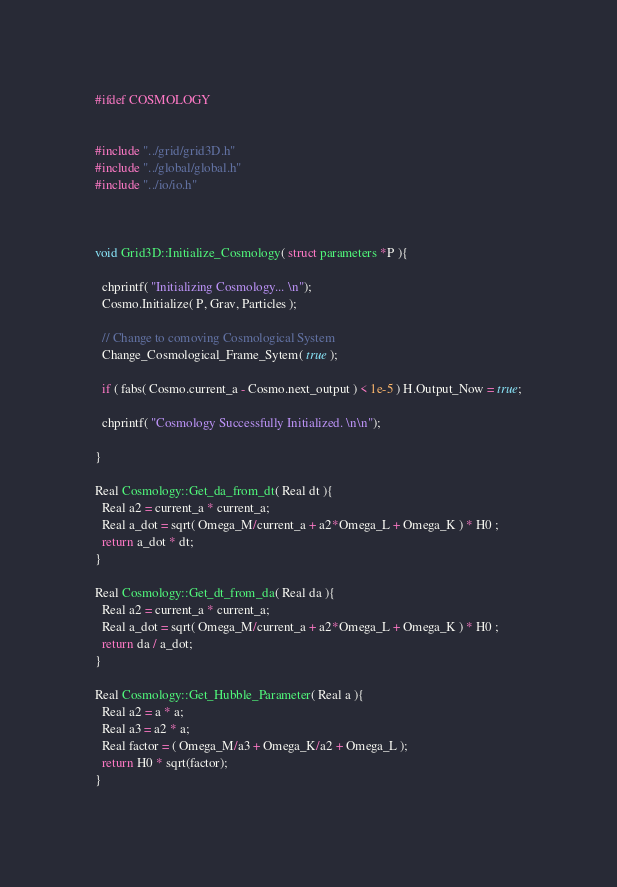<code> <loc_0><loc_0><loc_500><loc_500><_C++_>#ifdef COSMOLOGY


#include "../grid/grid3D.h"
#include "../global/global.h"
#include "../io/io.h"



void Grid3D::Initialize_Cosmology( struct parameters *P ){

  chprintf( "Initializing Cosmology... \n");
  Cosmo.Initialize( P, Grav, Particles );

  // Change to comoving Cosmological System
  Change_Cosmological_Frame_Sytem( true );

  if ( fabs( Cosmo.current_a - Cosmo.next_output ) < 1e-5 ) H.Output_Now = true;

  chprintf( "Cosmology Successfully Initialized. \n\n");

}

Real Cosmology::Get_da_from_dt( Real dt ){
  Real a2 = current_a * current_a;
  Real a_dot = sqrt( Omega_M/current_a + a2*Omega_L + Omega_K ) * H0 ;
  return a_dot * dt;
}

Real Cosmology::Get_dt_from_da( Real da ){
  Real a2 = current_a * current_a;
  Real a_dot = sqrt( Omega_M/current_a + a2*Omega_L + Omega_K ) * H0 ;
  return da / a_dot;
}

Real Cosmology::Get_Hubble_Parameter( Real a ){
  Real a2 = a * a;
  Real a3 = a2 * a;
  Real factor = ( Omega_M/a3 + Omega_K/a2 + Omega_L );
  return H0 * sqrt(factor);
}
</code> 